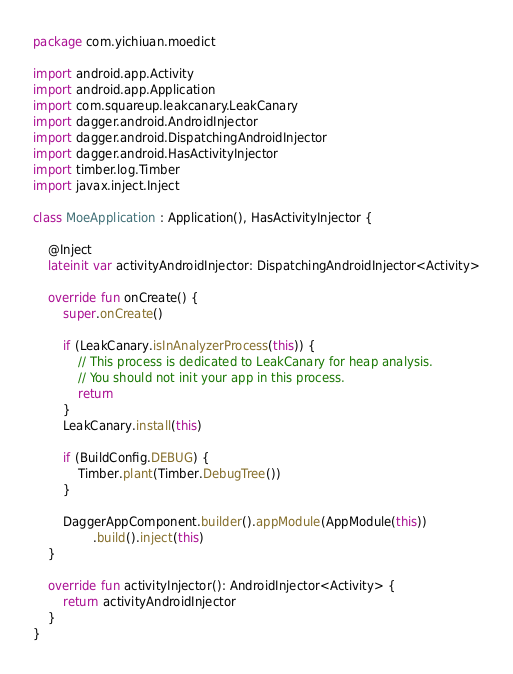<code> <loc_0><loc_0><loc_500><loc_500><_Kotlin_>package com.yichiuan.moedict

import android.app.Activity
import android.app.Application
import com.squareup.leakcanary.LeakCanary
import dagger.android.AndroidInjector
import dagger.android.DispatchingAndroidInjector
import dagger.android.HasActivityInjector
import timber.log.Timber
import javax.inject.Inject

class MoeApplication : Application(), HasActivityInjector {

    @Inject
    lateinit var activityAndroidInjector: DispatchingAndroidInjector<Activity>

    override fun onCreate() {
        super.onCreate()

        if (LeakCanary.isInAnalyzerProcess(this)) {
            // This process is dedicated to LeakCanary for heap analysis.
            // You should not init your app in this process.
            return
        }
        LeakCanary.install(this)

        if (BuildConfig.DEBUG) {
            Timber.plant(Timber.DebugTree())
        }

        DaggerAppComponent.builder().appModule(AppModule(this))
                .build().inject(this)
    }

    override fun activityInjector(): AndroidInjector<Activity> {
        return activityAndroidInjector
    }
}
</code> 